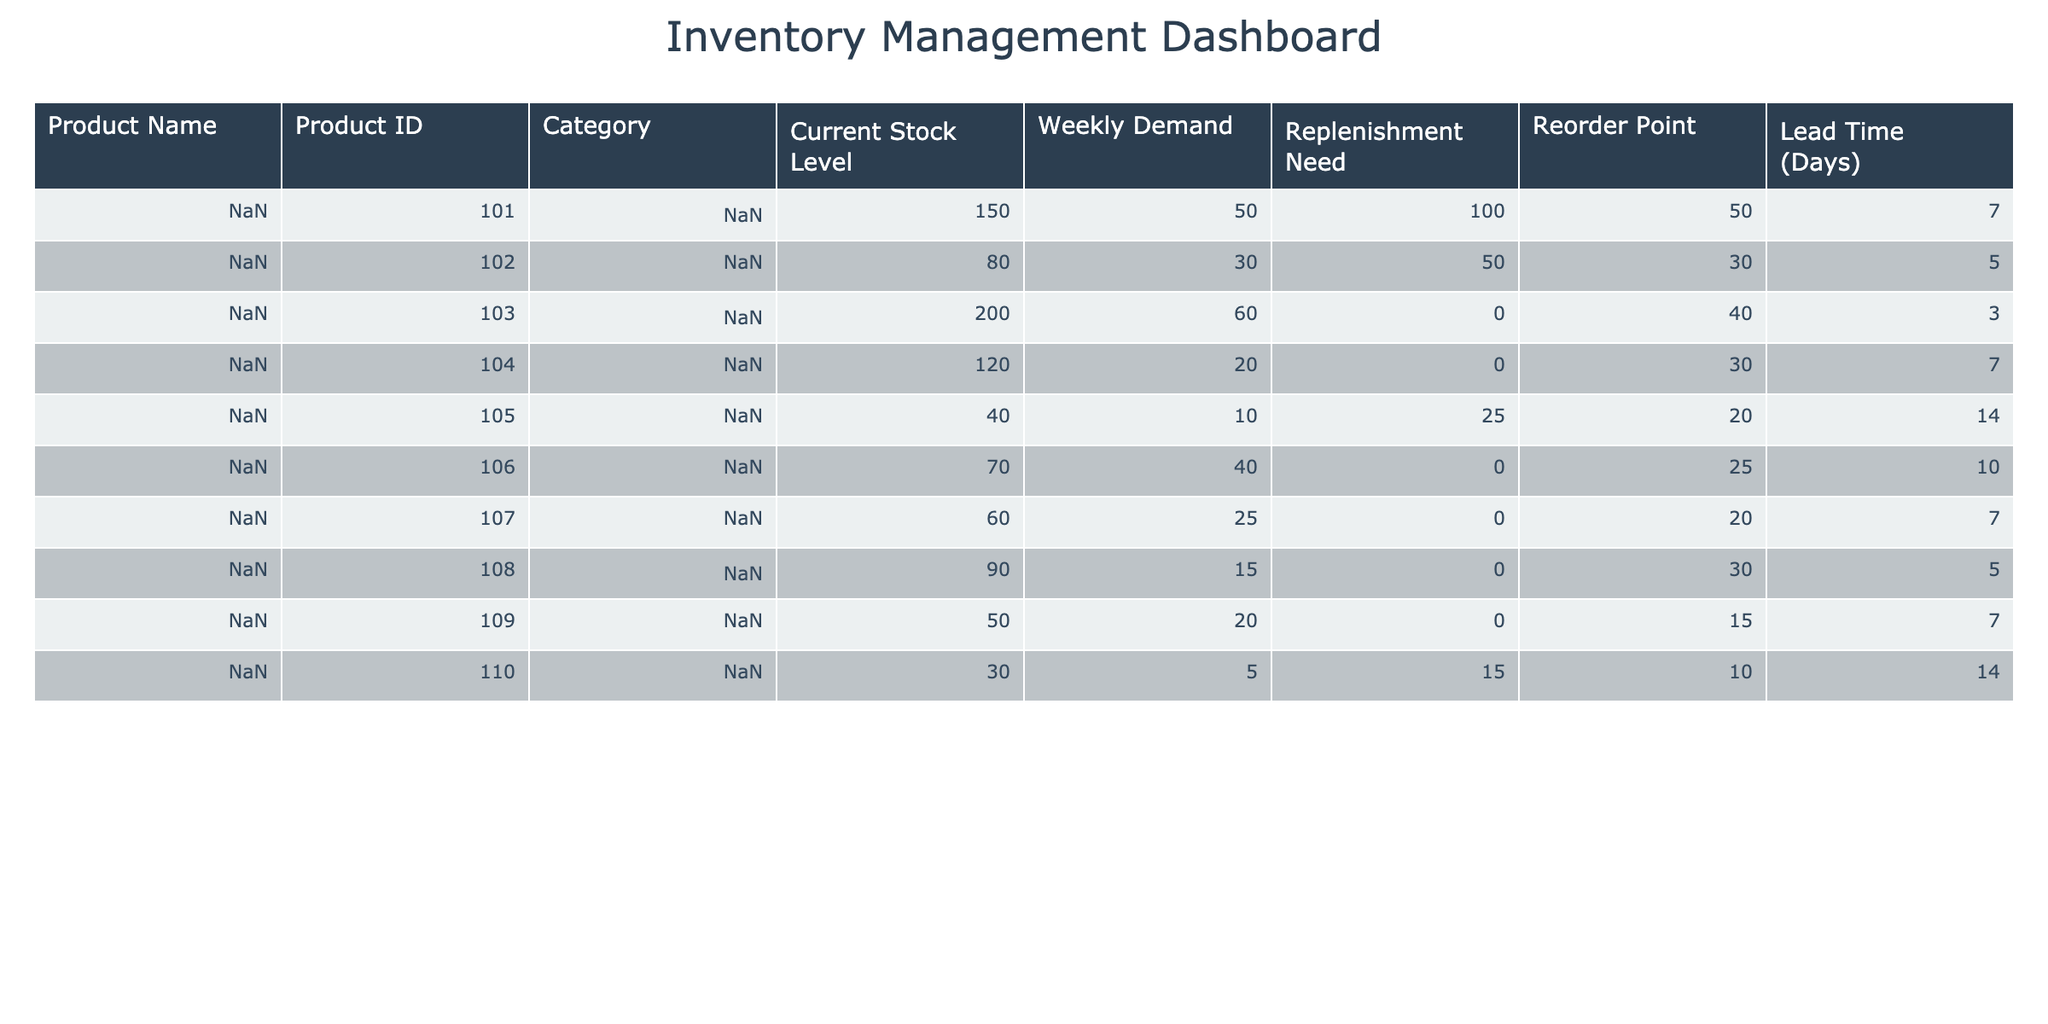What is the current stock level of Organic Almonds? The table lists the "Current Stock Level" for each product. Looking for "Organic Almonds" in the "Product Name" column, we find that its current stock level is 150.
Answer: 150 How many products have a replenishment need greater than 0? We can check the "Replenishment Need" column for each product. The products with a replenishment need greater than 0 are Organic Almonds (100), Coconut Oil (25), and Raw Honey (15), which totals 3 products.
Answer: 3 Is the reorder point for Quinoa higher than its current stock level? The "Reorder Point" for Quinoa is 30 and its "Current Stock Level" is 80. Since 80 is greater than 30, the reorder point is not higher. Therefore, the answer is no.
Answer: No What is the total weekly demand for all Nut & Seed products combined? The products in the "Nuts & Seeds" category are Organic Almonds and Chia Seeds. Their weekly demands are 50 and 60 respectively. Adding these gives us a total weekly demand of 50 + 60 = 110.
Answer: 110 Which product has the highest lead time, and what is that lead time? We can look through the "Lead Time (Days)" column to find the highest value. The maximum lead time is 14 days, and it corresponds to Coconut Oil and Raw Honey. Therefore, both products have the highest lead time of 14 days.
Answer: Coconut Oil, Raw Honey; 14 days What is the average weekly demand for products that need replenishment? The products that need replenishment are Organic Almonds, Coconut Oil, and Raw Honey, with weekly demands of 50, 10, and 5 respectively. Summing these gives us 50 + 10 + 5 = 65, and dividing by the number of products (3) gives us an average of 65/3 = 21.67.
Answer: 21.67 Does any product have current stock level less than its reorder point? We need to compare the "Current Stock Level" and "Reorder Point" for each product. Coconut Oil has a current stock of 40, which is less than its reorder point of 20, thus confirming that it is one such product.
Answer: Yes How many days lead time does the product with the lowest stock have? Checking the current stock levels, we find that the lowest is Raw Honey at 30. Referring to the "Lead Time (Days)" for Raw Honey, we see it is 14 days.
Answer: 14 days What is the total replenishment need for all products in the Condiments category? The Condiments category includes Coconut Oil and Almond Butter. Their replenishment needs are 25 and 0 respectively. Adding these gives us 25 + 0 = 25.
Answer: 25 